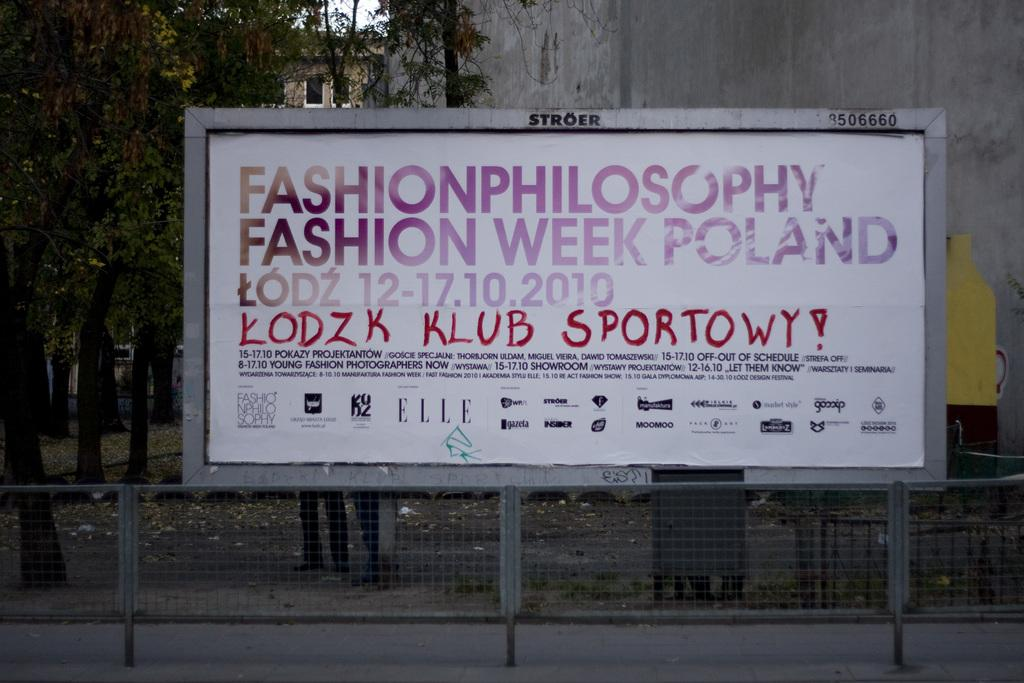<image>
Provide a brief description of the given image. Fashion week is being advertised on a billboard in Poland. 